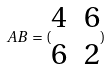Convert formula to latex. <formula><loc_0><loc_0><loc_500><loc_500>A B = ( \begin{matrix} 4 & 6 \\ 6 & 2 \end{matrix} )</formula> 